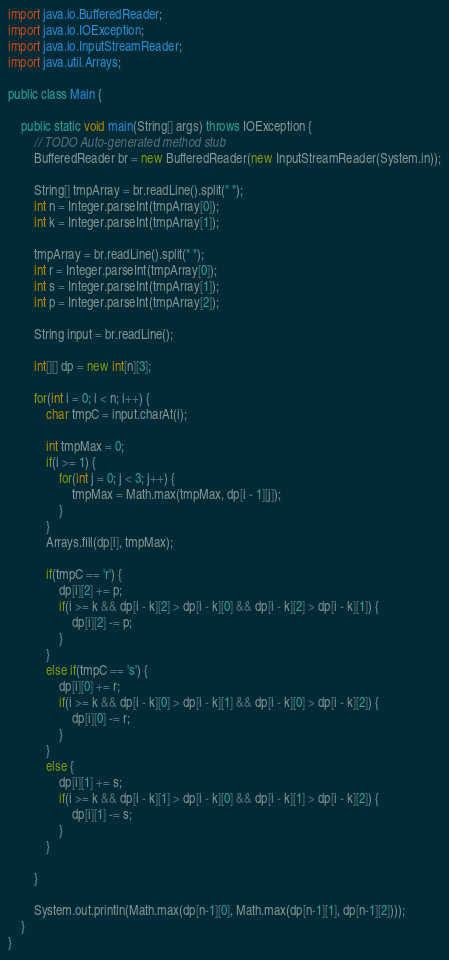<code> <loc_0><loc_0><loc_500><loc_500><_Java_>
import java.io.BufferedReader;
import java.io.IOException;
import java.io.InputStreamReader;
import java.util.Arrays;

public class Main {

	public static void main(String[] args) throws IOException {
		// TODO Auto-generated method stub
		BufferedReader br = new BufferedReader(new InputStreamReader(System.in));
		
		String[] tmpArray = br.readLine().split(" ");
		int n = Integer.parseInt(tmpArray[0]);
		int k = Integer.parseInt(tmpArray[1]);
		
		tmpArray = br.readLine().split(" ");
		int r = Integer.parseInt(tmpArray[0]);
		int s = Integer.parseInt(tmpArray[1]);
		int p = Integer.parseInt(tmpArray[2]);
		
		String input = br.readLine();
		
		int[][] dp = new int[n][3];
		
		for(int i = 0; i < n; i++) {
			char tmpC = input.charAt(i);
			
			int tmpMax = 0;
			if(i >= 1) {
				for(int j = 0; j < 3; j++) {
					tmpMax = Math.max(tmpMax, dp[i - 1][j]);
				}
			}
			Arrays.fill(dp[i], tmpMax);
			
			if(tmpC == 'r') {
				dp[i][2] += p;
				if(i >= k && dp[i - k][2] > dp[i - k][0] && dp[i - k][2] > dp[i - k][1]) {
					dp[i][2] -= p;
				}
			}
			else if(tmpC == 's') {
				dp[i][0] += r;
				if(i >= k && dp[i - k][0] > dp[i - k][1] && dp[i - k][0] > dp[i - k][2]) {
					dp[i][0] -= r;
				}
			}
			else {
				dp[i][1] += s;
				if(i >= k && dp[i - k][1] > dp[i - k][0] && dp[i - k][1] > dp[i - k][2]) {
					dp[i][1] -= s;
				}
			}
			
		}
		
		System.out.println(Math.max(dp[n-1][0], Math.max(dp[n-1][1], dp[n-1][2])));
	}
}
</code> 